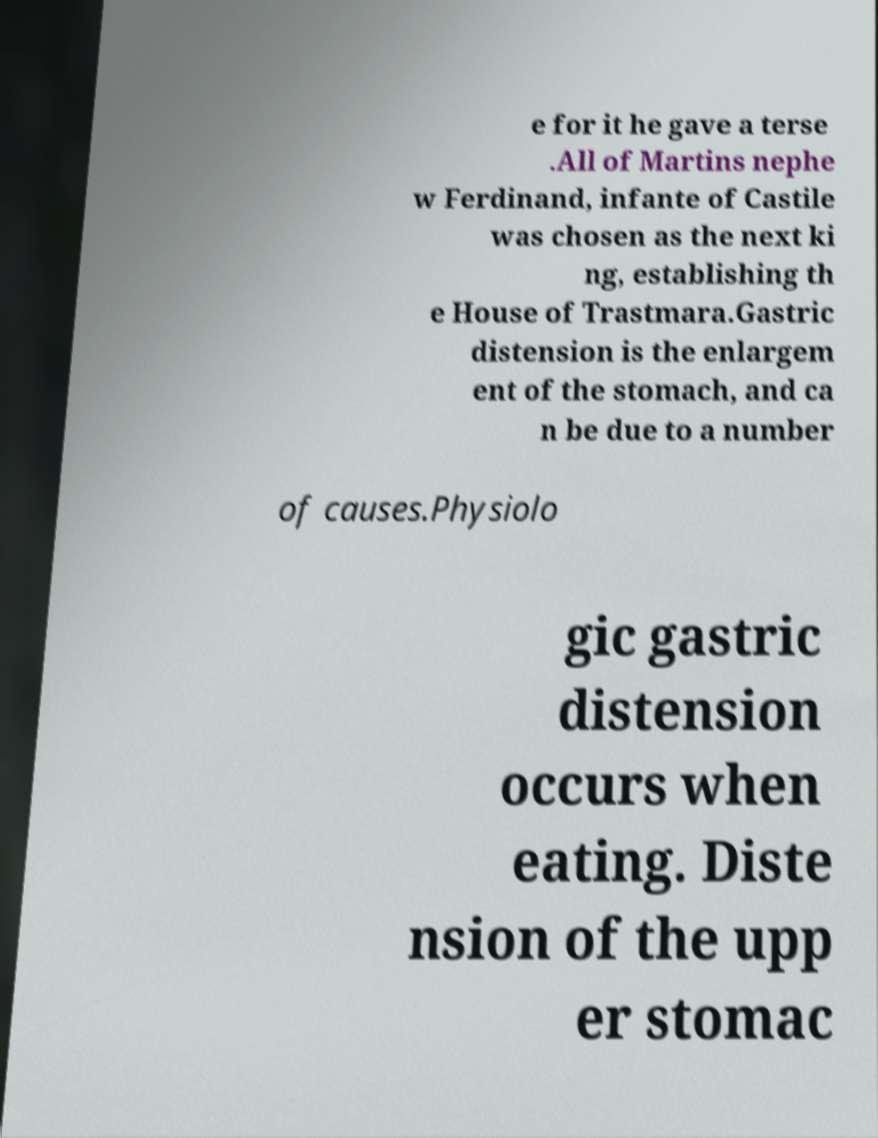Please identify and transcribe the text found in this image. e for it he gave a terse .All of Martins nephe w Ferdinand, infante of Castile was chosen as the next ki ng, establishing th e House of Trastmara.Gastric distension is the enlargem ent of the stomach, and ca n be due to a number of causes.Physiolo gic gastric distension occurs when eating. Diste nsion of the upp er stomac 